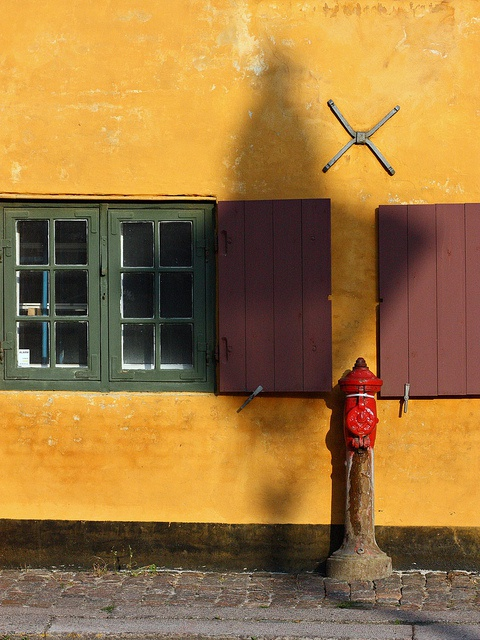Describe the objects in this image and their specific colors. I can see a fire hydrant in orange, black, maroon, gray, and tan tones in this image. 